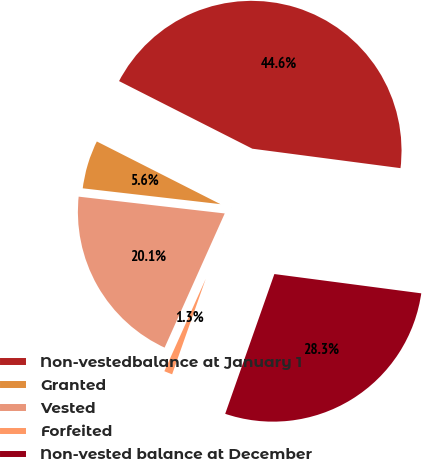Convert chart to OTSL. <chart><loc_0><loc_0><loc_500><loc_500><pie_chart><fcel>Non-vestedbalance at January 1<fcel>Granted<fcel>Vested<fcel>Forfeited<fcel>Non-vested balance at December<nl><fcel>44.61%<fcel>5.65%<fcel>20.12%<fcel>1.32%<fcel>28.31%<nl></chart> 